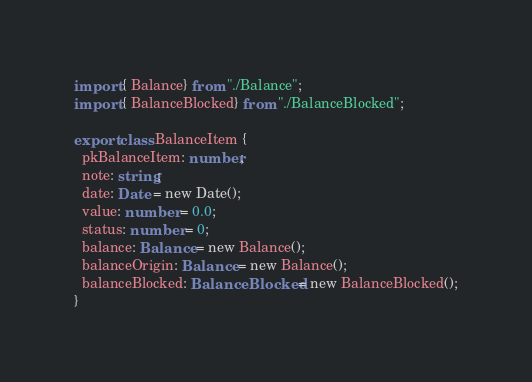<code> <loc_0><loc_0><loc_500><loc_500><_TypeScript_>import { Balance} from "./Balance";
import { BalanceBlocked} from "./BalanceBlocked";

export class BalanceItem {
  pkBalanceItem: number;
  note: string;
  date: Date = new Date();
  value: number = 0.0;
  status: number = 0;
  balance: Balance = new Balance();
  balanceOrigin: Balance = new Balance();
  balanceBlocked: BalanceBlocked = new BalanceBlocked();
}</code> 